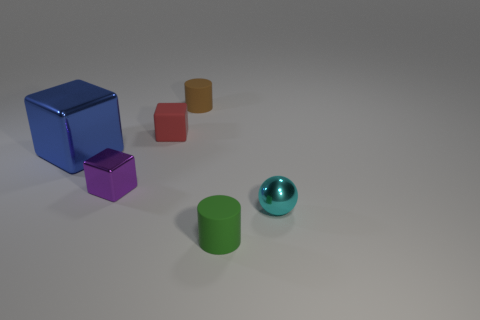Subtract 1 blocks. How many blocks are left? 2 Subtract all small blocks. How many blocks are left? 1 Add 1 large rubber cylinders. How many objects exist? 7 Subtract all balls. How many objects are left? 5 Subtract 0 green balls. How many objects are left? 6 Subtract all purple blocks. Subtract all large purple metal blocks. How many objects are left? 5 Add 6 spheres. How many spheres are left? 7 Add 6 metal things. How many metal things exist? 9 